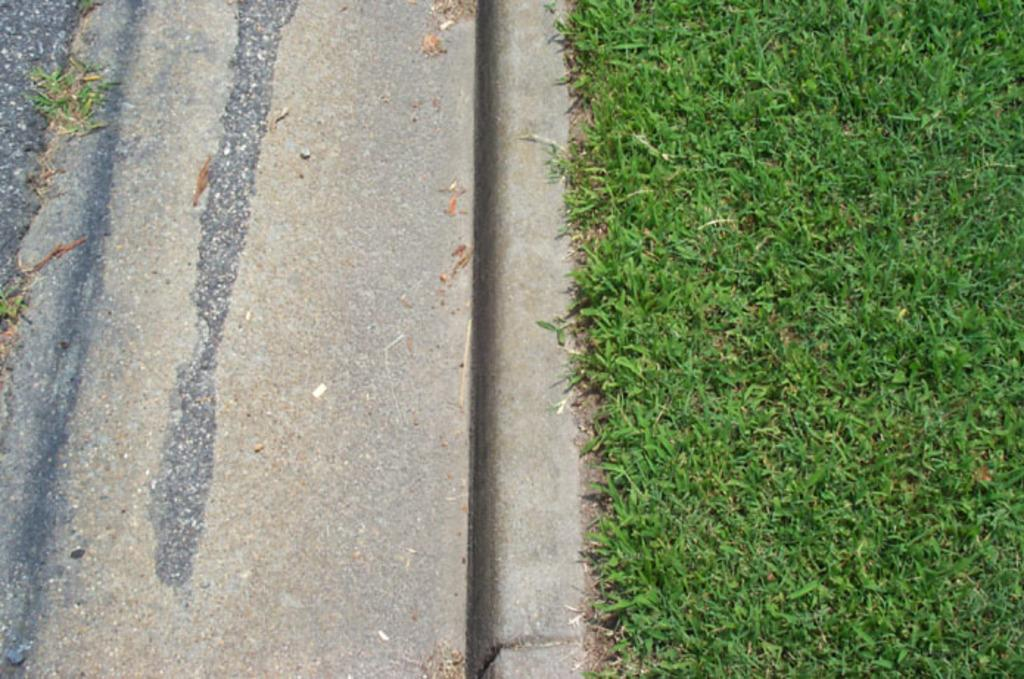What type of vegetation is on the right side of the image? There is grass on the right side of the image. What can be found on the left side of the image? There are dry leaves, grass, and dust on the left side of the image. What type of surface is visible on the left side of the image? There is a road on the left side of the image. What type of wall can be seen on the right side of the image? There is no wall present on the right side of the image; it features grass. What color are the trousers worn by the person in the image? There is no person present in the image, so it is not possible to determine the color of their trousers. 